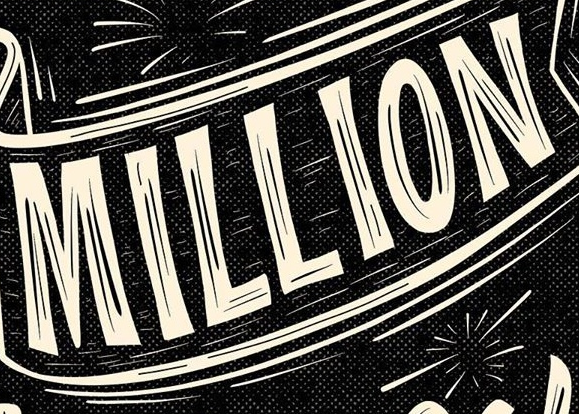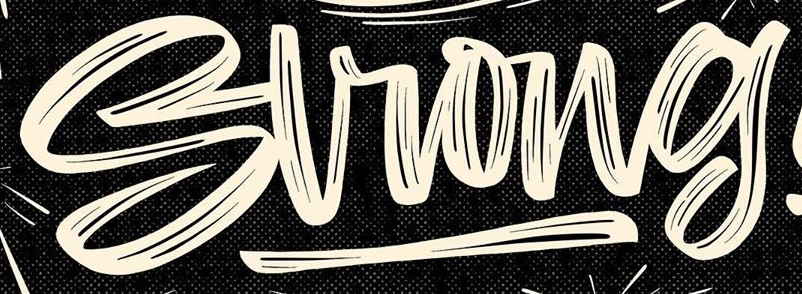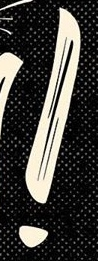What text appears in these images from left to right, separated by a semicolon? MILLION; Strong; ! 